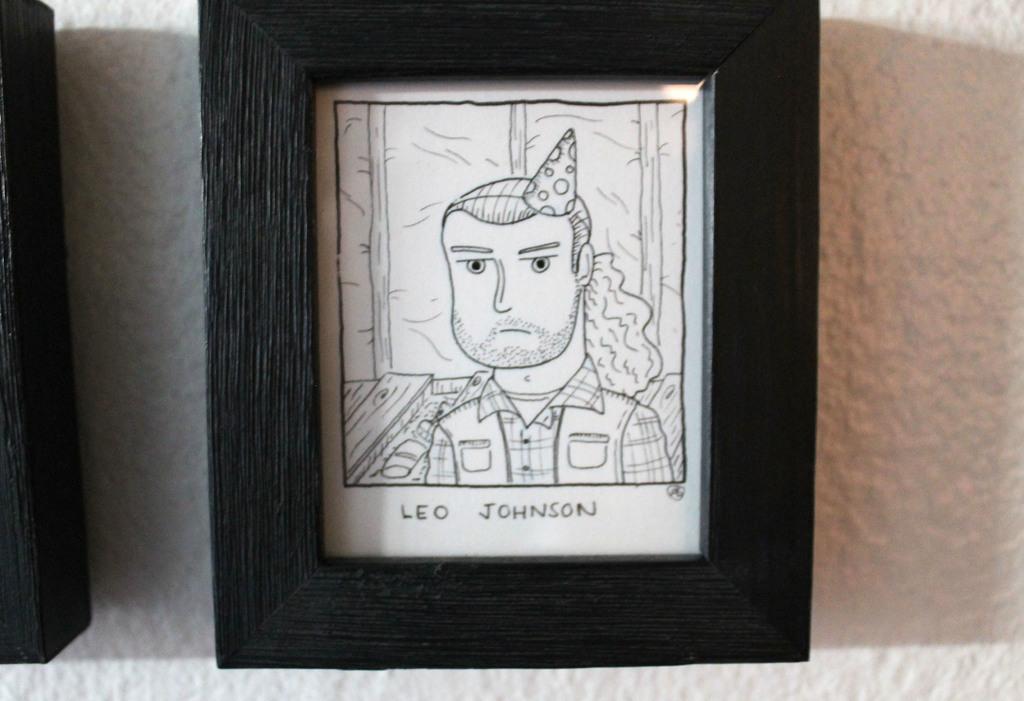What name is wrote below the picture?
Provide a short and direct response. Leo johnson. Who is this a picture of?
Provide a succinct answer. Leo johnson. 